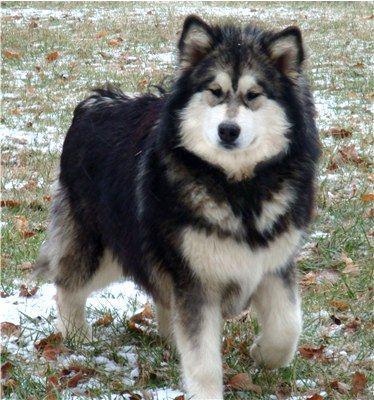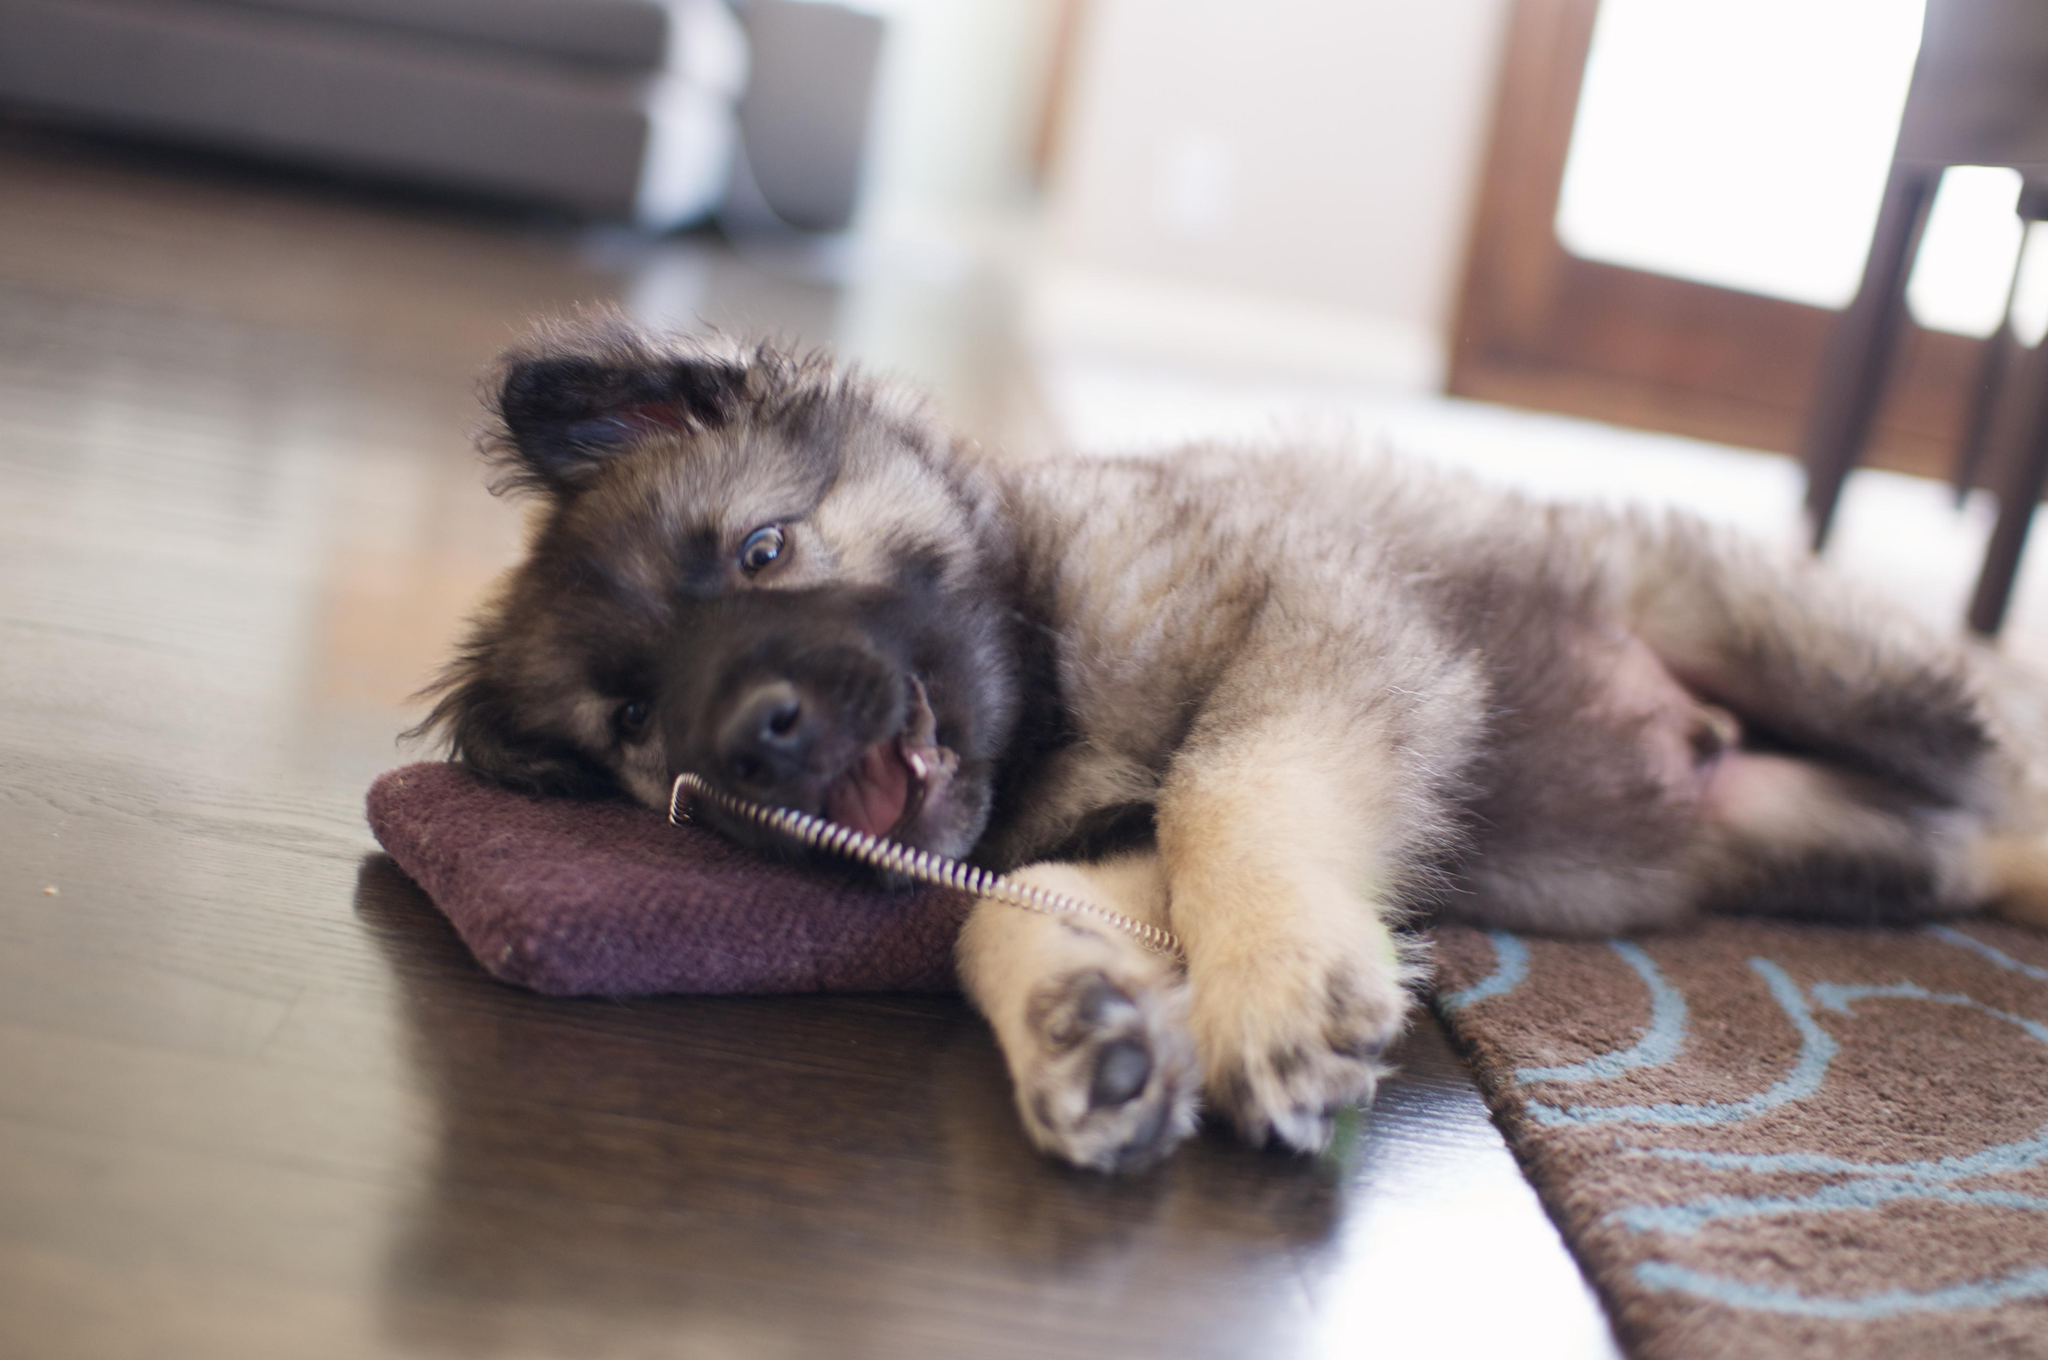The first image is the image on the left, the second image is the image on the right. Analyze the images presented: Is the assertion "The left image features one dog, which is facing rightward, and the right image features a reclining dog with its head upright and body facing forward." valid? Answer yes or no. No. The first image is the image on the left, the second image is the image on the right. Assess this claim about the two images: "There is at least one human in the image pair.". Correct or not? Answer yes or no. No. 